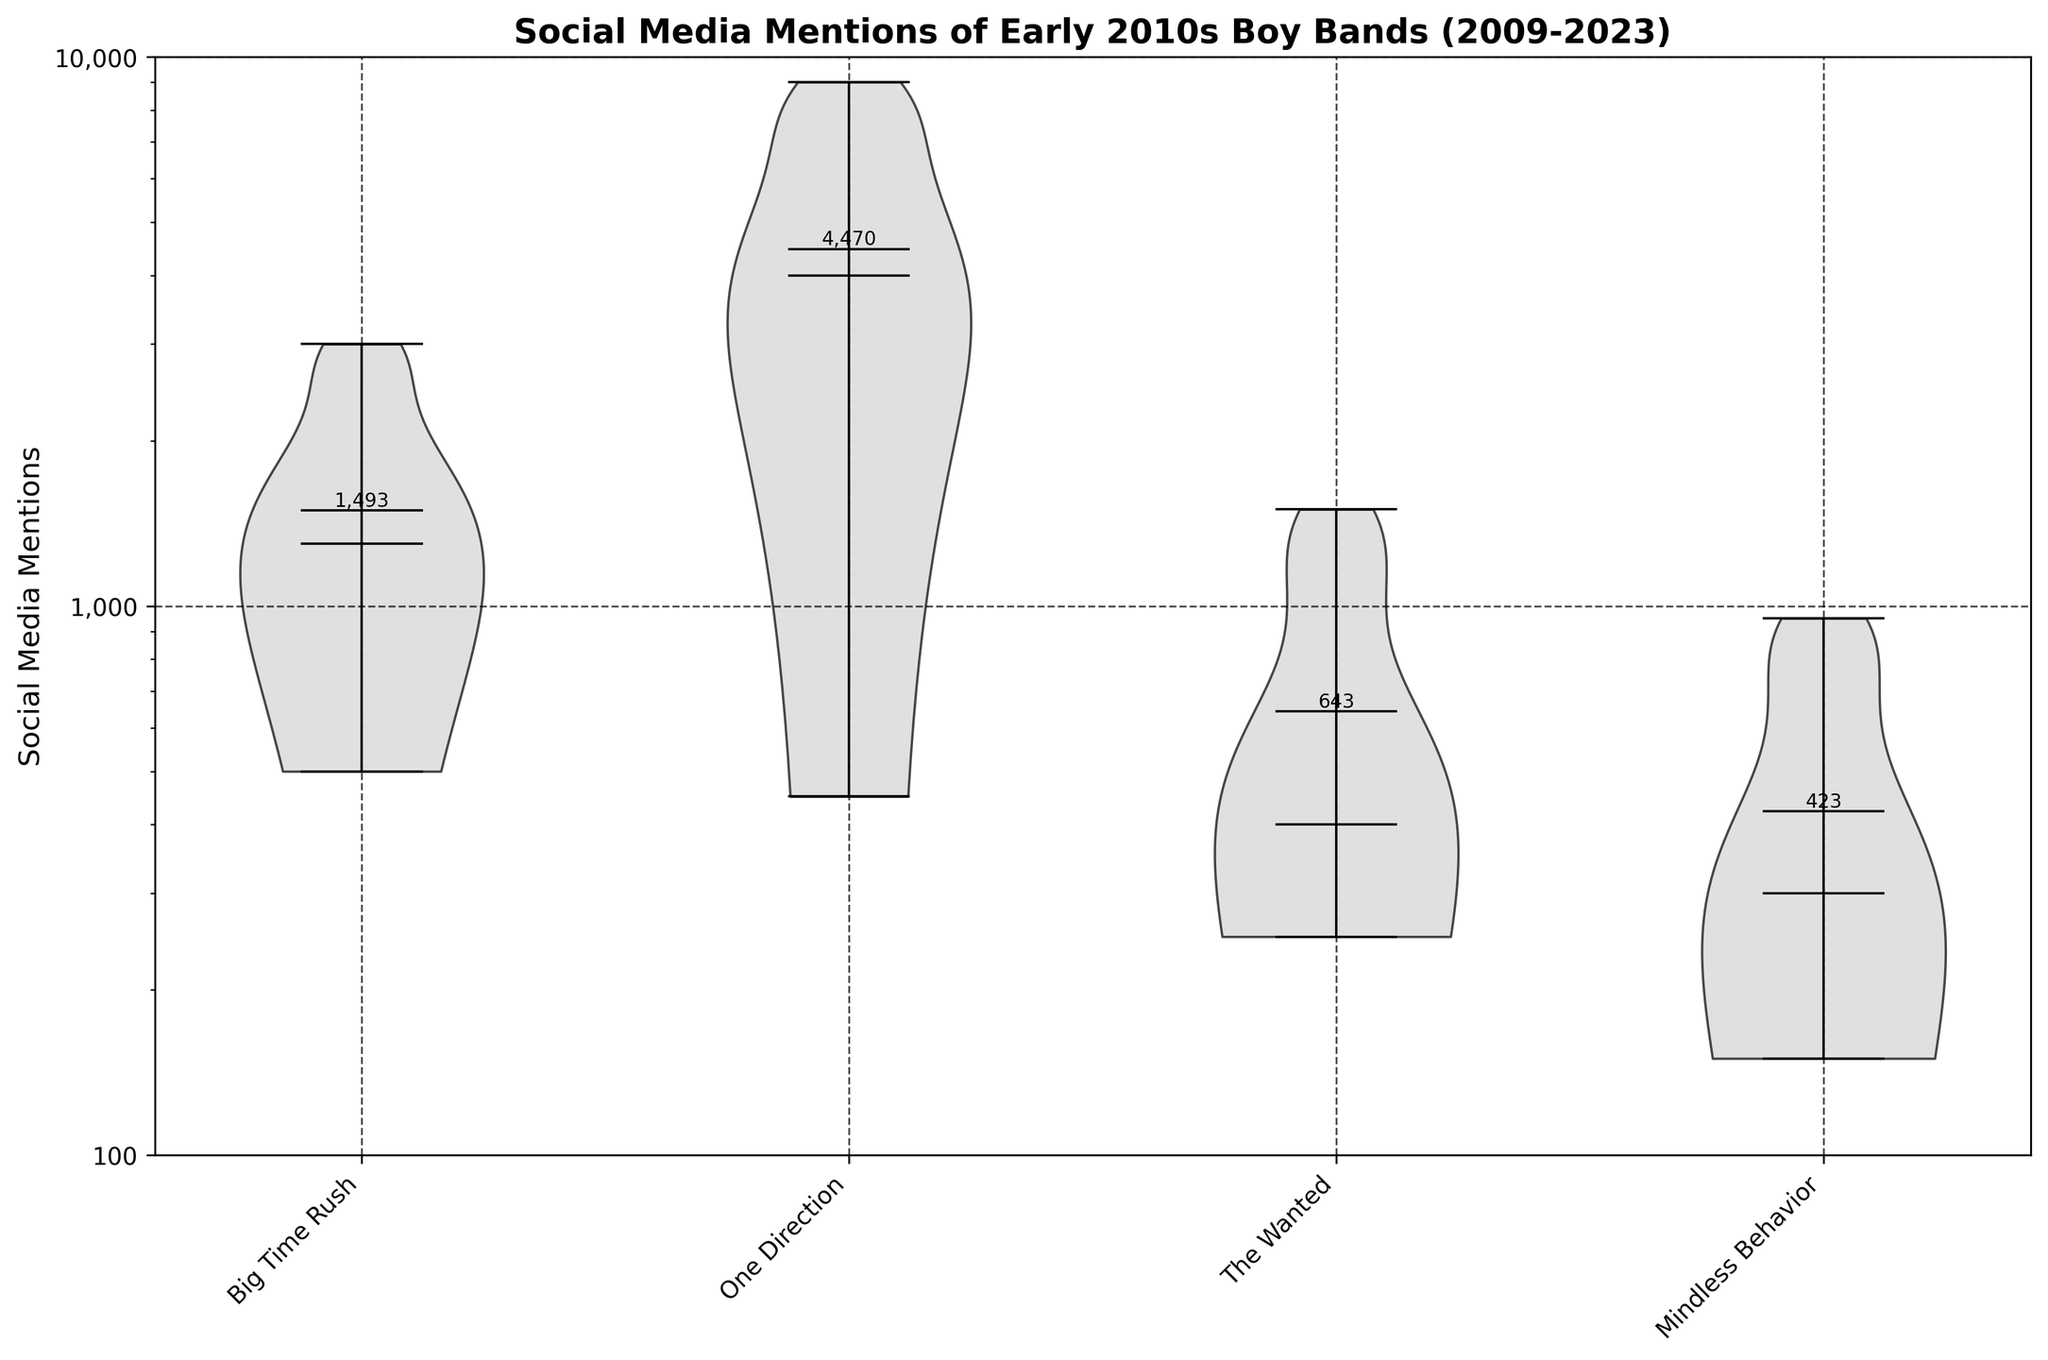What is the title of the figure showing? The title of the figure is "Social Media Mentions of Early 2010s Boy Bands (2009-2023)". This can be found at the top of the plot, giving a clear overview of what the data represents.
Answer: Social Media Mentions of Early 2010s Boy Bands (2009-2023) Which boy band shows the highest social media mentions? By looking at the highest point of the violin plots, One Direction clearly reaches the top mark in terms of social media mentions around 2015 with 9000 mentions, which is higher than any other band.
Answer: One Direction What is the range of mentions for Big Time Rush from 2009 to 2023? The range is the difference between the maximum and minimum values. Big Time Rush has mentions ranging from 500 (2009) to 3000 (2012). Therefore, the range is 3000 - 500 = 2500.
Answer: 2500 Which band has the widest distribution of mentions according to their violin plot? The width of the violin plot represents the density of data points at different values. One Direction's violin plot is the widest, indicating a broader range of mentions and density over the years.
Answer: One Direction How does the mean number of mentions for Big Time Rush compare to that of Mindless Behavior? By observing the mean points annotated on the plots, the mean value for Big Time Rush is higher than that of Mindless Behavior. Big Time Rush's mentions are generally more numerous across the years.
Answer: Big Time Rush's mean is higher What is the median number of mentions for One Direction? The median is the middle value shown by the horizontal line inside the violin plot. For One Direction, this line hovers around 4000 mentions.
Answer: 4000 Which year did Big Time Rush have the highest number of social media mentions? By examining the peaks on the violin plot for Big Time Rush, they reached their highest mentions in 2012 with 3000 mentions.
Answer: 2012 Between 2016 and 2023, which band had the least social media mentions? During this period, Mindless Behavior consistently has the smallest mentions, never surpassing 300, which is evident from examining the violin plot's range.
Answer: Mindless Behavior Which band had a significant decrease in social media mentions after 2015? Observing the trends, One Direction shows a notable decrease in mentions from around 9000 in 2015 to lower values in subsequent years.
Answer: One Direction How do the social media mentions for The Wanted and Big Time Rush compare in 2023? By checking the data points for 2023, Big Time Rush has 1800 mentions, whereas The Wanted has only 300 mentions. Big Time Rush has significantly more mentions.
Answer: Big Time Rush has more mentions 